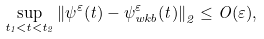<formula> <loc_0><loc_0><loc_500><loc_500>\sup _ { t _ { 1 } < t < t _ { 2 } } { \| \psi ^ { \varepsilon } ( t ) - \psi ^ { \varepsilon } _ { w k b } ( t ) \| } _ { 2 } \leq O ( \varepsilon ) ,</formula> 